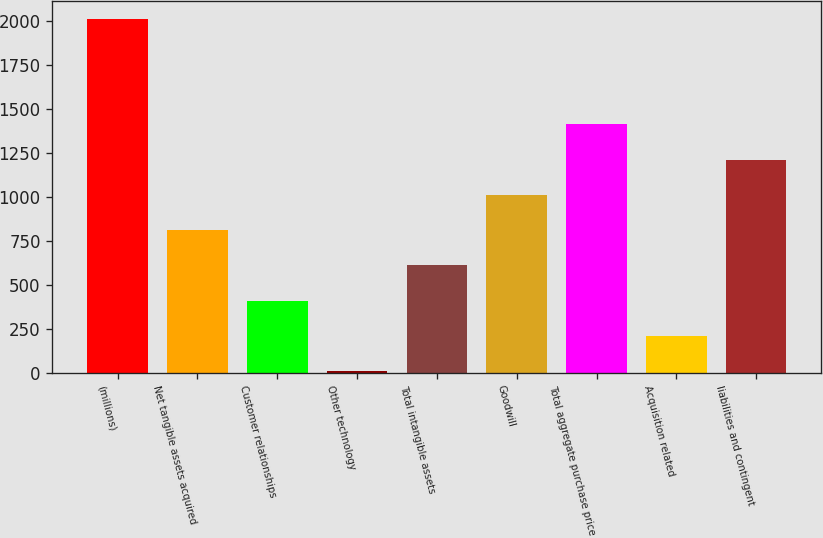Convert chart to OTSL. <chart><loc_0><loc_0><loc_500><loc_500><bar_chart><fcel>(millions)<fcel>Net tangible assets acquired<fcel>Customer relationships<fcel>Other technology<fcel>Total intangible assets<fcel>Goodwill<fcel>Total aggregate purchase price<fcel>Acquisition related<fcel>liabilities and contingent<nl><fcel>2015<fcel>811.22<fcel>409.96<fcel>8.7<fcel>610.59<fcel>1011.85<fcel>1413.11<fcel>209.33<fcel>1212.48<nl></chart> 